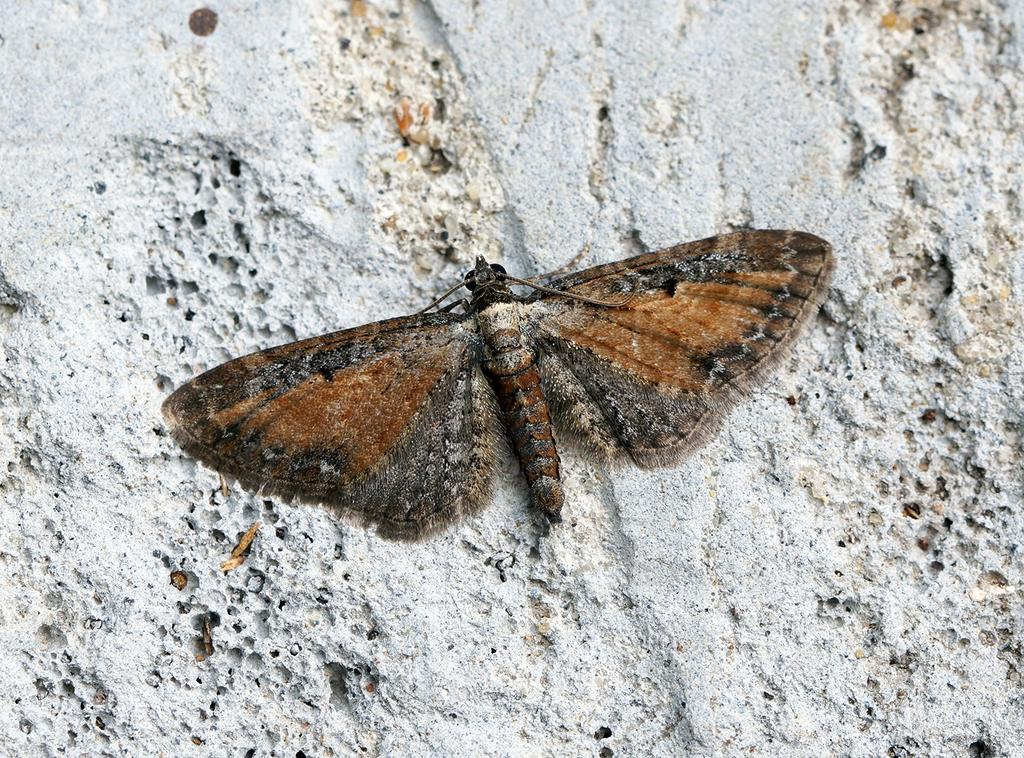What type of insect is present in the image? There is a brown color butterfly in the image. What is the background of the butterfly in the image? The butterfly is on a white wall. What is the writer's regret in the image? There is no writer or regret present in the image; it features a brown color butterfly on a white wall. 